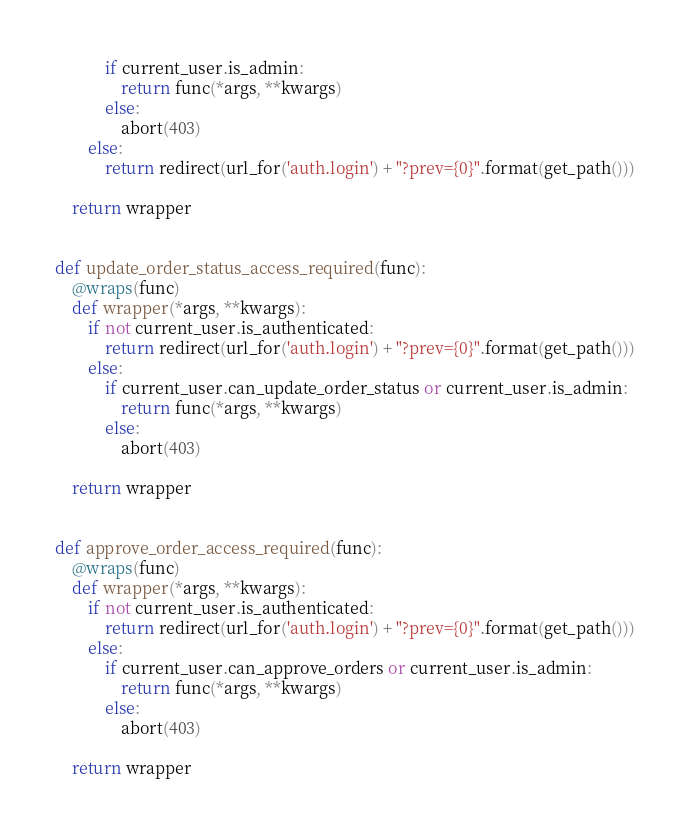<code> <loc_0><loc_0><loc_500><loc_500><_Python_>            if current_user.is_admin:
                return func(*args, **kwargs)
            else:
                abort(403)
        else:
            return redirect(url_for('auth.login') + "?prev={0}".format(get_path()))

    return wrapper


def update_order_status_access_required(func):
    @wraps(func)
    def wrapper(*args, **kwargs):
        if not current_user.is_authenticated:
            return redirect(url_for('auth.login') + "?prev={0}".format(get_path()))
        else:
            if current_user.can_update_order_status or current_user.is_admin:
                return func(*args, **kwargs)
            else:
                abort(403)

    return wrapper


def approve_order_access_required(func):
    @wraps(func)
    def wrapper(*args, **kwargs):
        if not current_user.is_authenticated:
            return redirect(url_for('auth.login') + "?prev={0}".format(get_path()))
        else:
            if current_user.can_approve_orders or current_user.is_admin:
                return func(*args, **kwargs)
            else:
                abort(403)

    return wrapper
</code> 